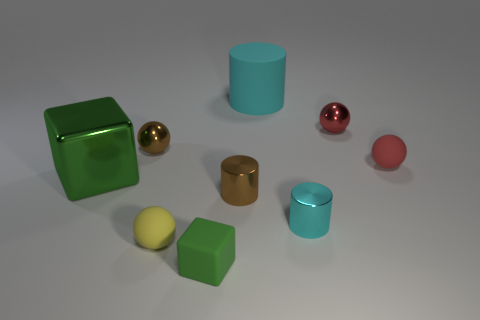Is there anything else that is the same size as the cyan metallic thing?
Offer a very short reply. Yes. There is a brown thing that is in front of the object to the right of the small red metallic thing; what is it made of?
Give a very brief answer. Metal. Do the red metal ball and the red matte thing have the same size?
Your response must be concise. Yes. How many things are green things that are left of the yellow sphere or large cyan matte cylinders?
Make the answer very short. 2. What is the shape of the green object in front of the cyan cylinder in front of the large cyan cylinder?
Offer a very short reply. Cube. There is a green rubber object; does it have the same size as the cyan thing that is in front of the brown ball?
Provide a short and direct response. Yes. What is the material of the tiny brown object that is left of the green matte block?
Ensure brevity in your answer.  Metal. What number of rubber objects are both right of the large cyan matte cylinder and in front of the small yellow object?
Your answer should be compact. 0. What is the material of the other cylinder that is the same size as the brown metal cylinder?
Ensure brevity in your answer.  Metal. There is a block that is in front of the tiny cyan metal cylinder; does it have the same size as the shiny cylinder on the right side of the large cyan cylinder?
Provide a succinct answer. Yes. 